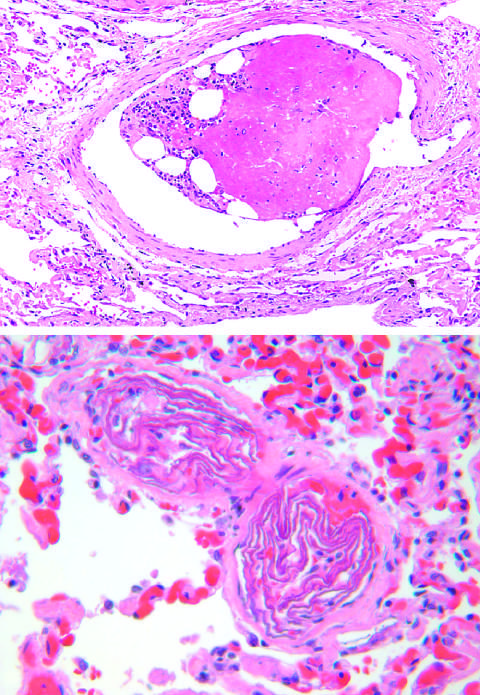how many small pulmonary arterioles are packed with laminated swirls of fetal squamous cells?
Answer the question using a single word or phrase. Two 